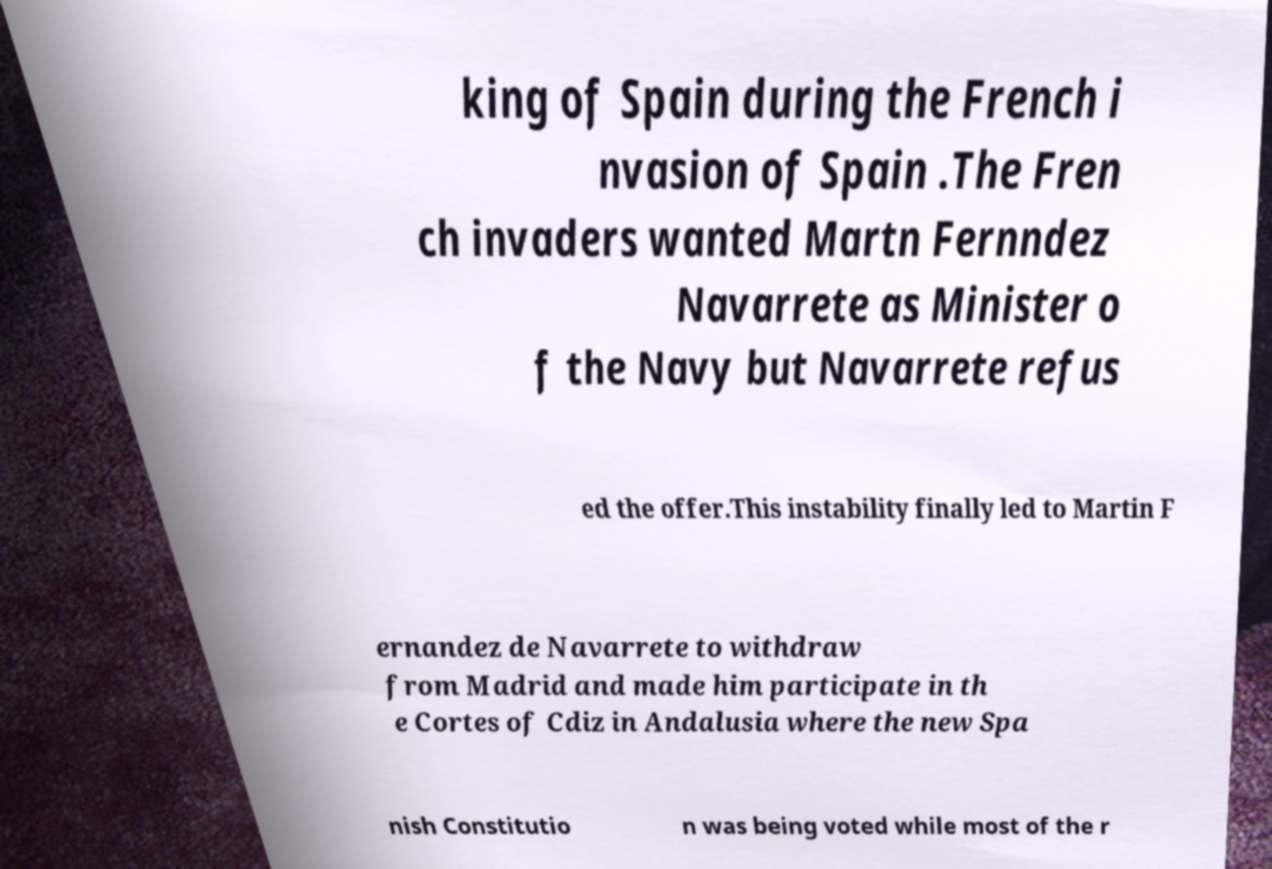I need the written content from this picture converted into text. Can you do that? king of Spain during the French i nvasion of Spain .The Fren ch invaders wanted Martn Fernndez Navarrete as Minister o f the Navy but Navarrete refus ed the offer.This instability finally led to Martin F ernandez de Navarrete to withdraw from Madrid and made him participate in th e Cortes of Cdiz in Andalusia where the new Spa nish Constitutio n was being voted while most of the r 